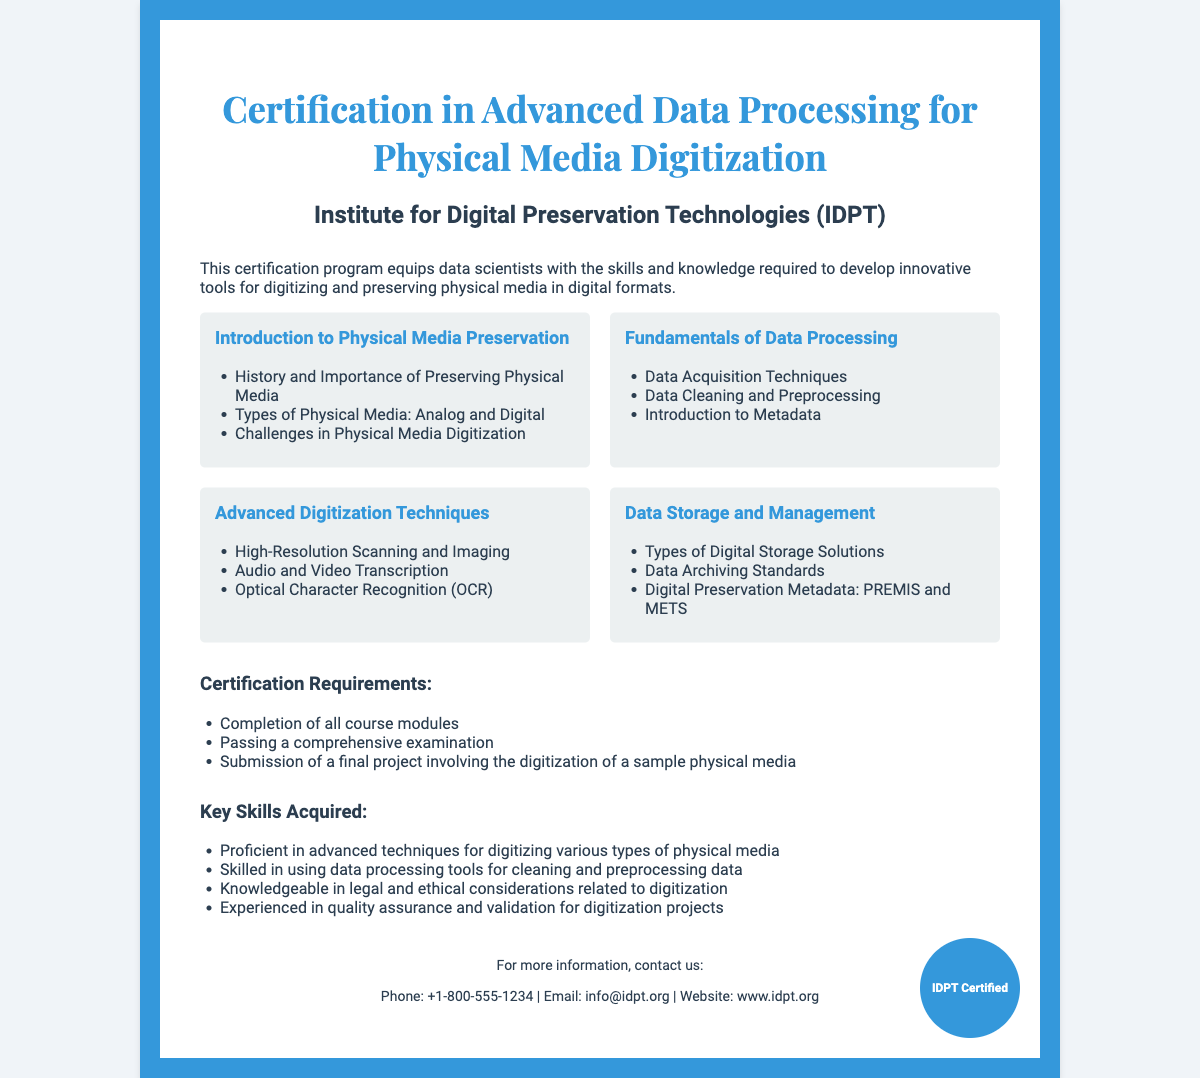What is the title of the certification? The title of the certification is prominently displayed at the top of the document.
Answer: Certification in Advanced Data Processing for Physical Media Digitization Who is the issuing institute? The second heading clearly states the name of the issuing institute.
Answer: Institute for Digital Preservation Technologies (IDPT) How many modules are listed in the certification details? Counting the individual module entries reveals the total number of modules.
Answer: 4 What is the first topic covered in the modules? The first module title gives an overview of the initial topic taught.
Answer: Introduction to Physical Media Preservation What is required for certification completion? The document lists the specific requirements necessary to obtain the certification.
Answer: Completion of all course modules Which skill involves legal considerations in digitization? One of the key skills explicitly mentions legal aspects of the process.
Answer: Knowledgeable in legal and ethical considerations related to digitization What type of project must be submitted for certification? The requirements outline the nature of the project that needs to be completed.
Answer: Final project involving the digitization of a sample physical media What is the contact email provided in the document? The footer section has contact information including an email address.
Answer: info@idpt.org 